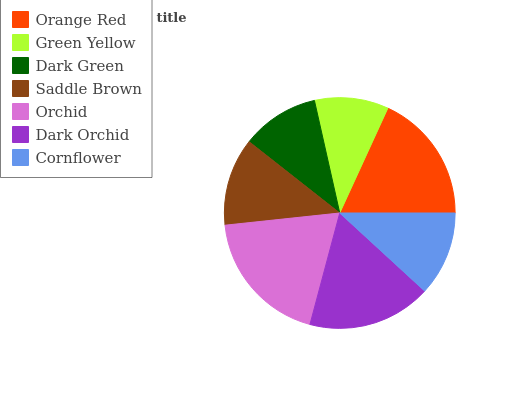Is Green Yellow the minimum?
Answer yes or no. Yes. Is Orchid the maximum?
Answer yes or no. Yes. Is Dark Green the minimum?
Answer yes or no. No. Is Dark Green the maximum?
Answer yes or no. No. Is Dark Green greater than Green Yellow?
Answer yes or no. Yes. Is Green Yellow less than Dark Green?
Answer yes or no. Yes. Is Green Yellow greater than Dark Green?
Answer yes or no. No. Is Dark Green less than Green Yellow?
Answer yes or no. No. Is Saddle Brown the high median?
Answer yes or no. Yes. Is Saddle Brown the low median?
Answer yes or no. Yes. Is Orchid the high median?
Answer yes or no. No. Is Dark Green the low median?
Answer yes or no. No. 